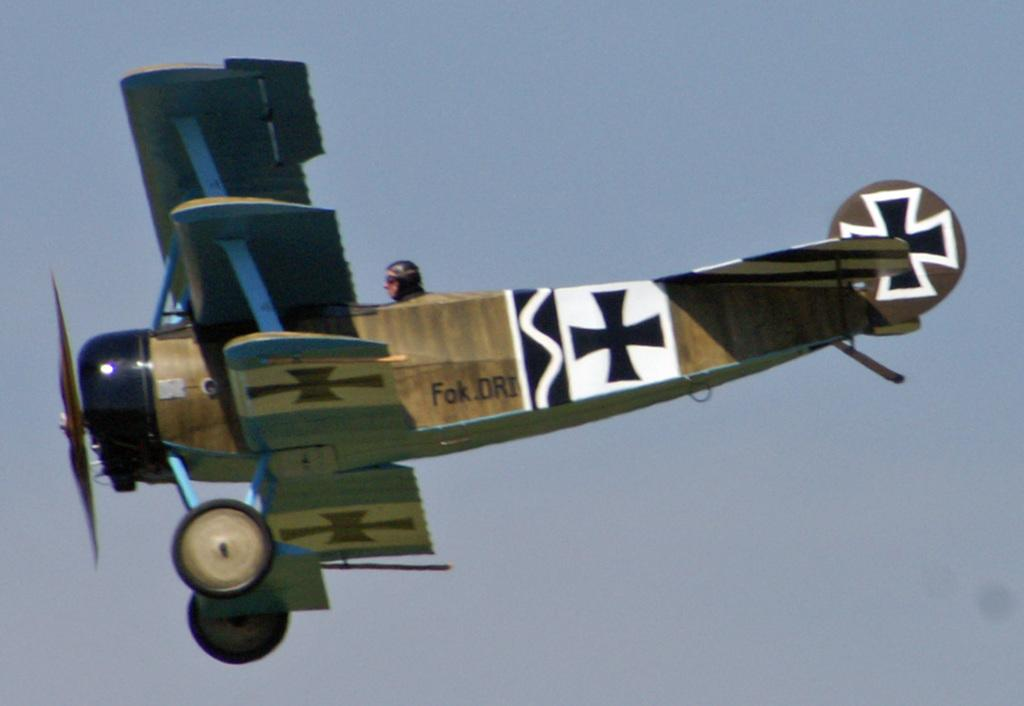What is the main subject of the image? The main subject of the image is a plane. Where is the plane located in the image? The plane is in the air. Can you describe the person in the image? There is a person sitting in the plane. What can be seen in the background of the image? The sky is visible in the background of the image. What type of trouble is the plane experiencing in the image? There is no indication of trouble in the image; the plane is simply flying in the air. Can you describe the person's home in the image? There is no home present in the image; it features a plane in the air. 